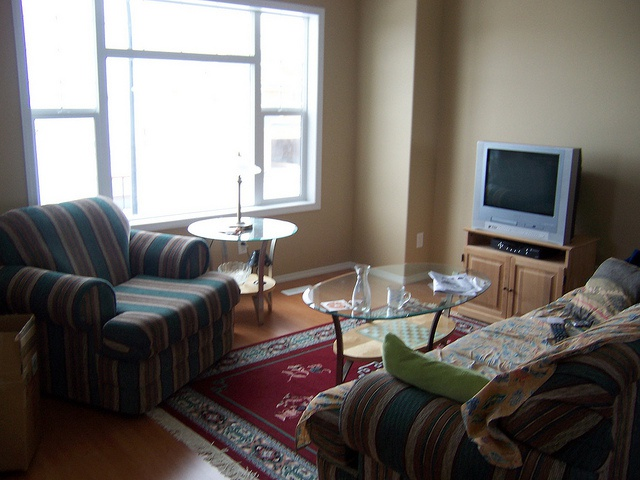Describe the objects in this image and their specific colors. I can see couch in gray, black, darkgray, and maroon tones, chair in gray, black, and blue tones, tv in gray, black, and darkgray tones, vase in gray, darkgray, and lightgray tones, and book in gray, darkgray, and lightblue tones in this image. 